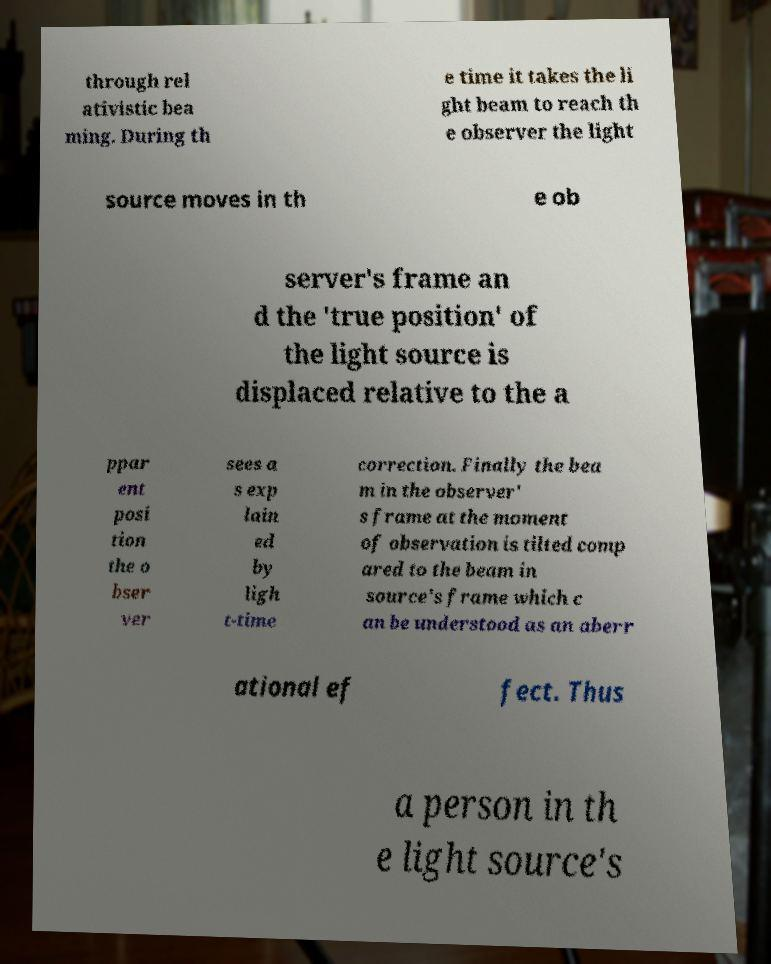Could you extract and type out the text from this image? through rel ativistic bea ming. During th e time it takes the li ght beam to reach th e observer the light source moves in th e ob server's frame an d the 'true position' of the light source is displaced relative to the a ppar ent posi tion the o bser ver sees a s exp lain ed by ligh t-time correction. Finally the bea m in the observer' s frame at the moment of observation is tilted comp ared to the beam in source's frame which c an be understood as an aberr ational ef fect. Thus a person in th e light source's 